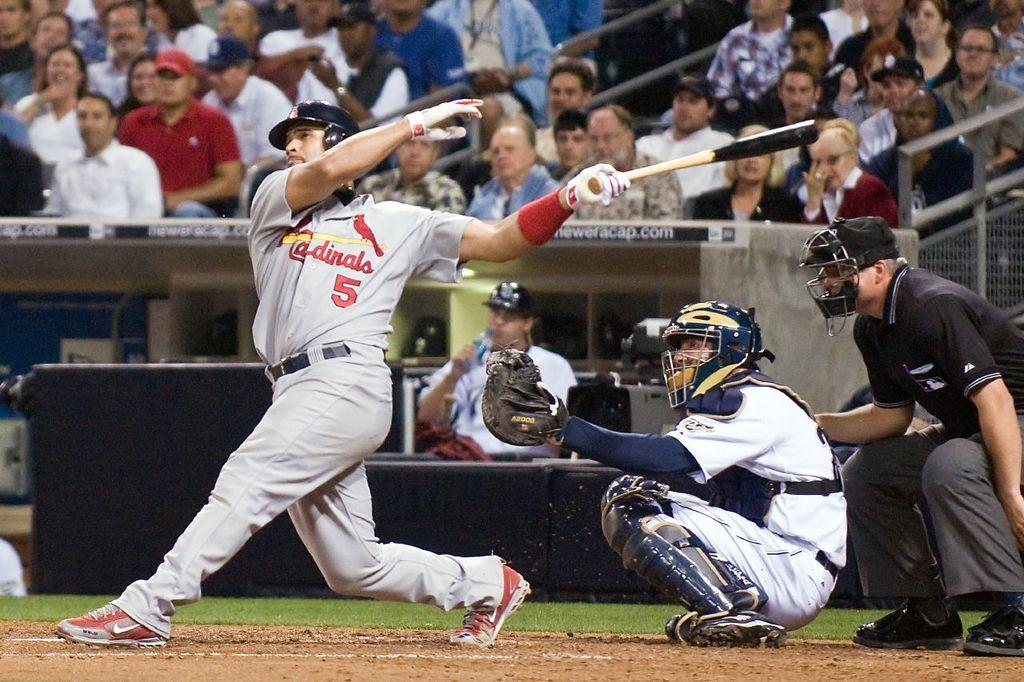<image>
Render a clear and concise summary of the photo. A player is at bat for the baseball team the Cardinals 